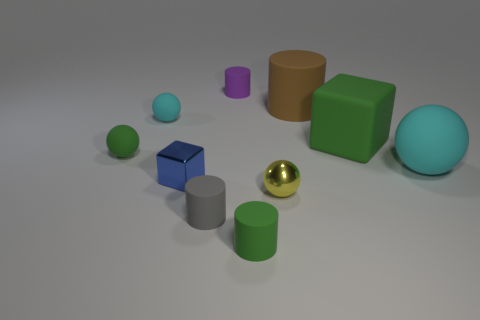Subtract all green rubber spheres. How many spheres are left? 3 Subtract all purple cylinders. How many cylinders are left? 3 Subtract all red balls. Subtract all blue cylinders. How many balls are left? 4 Subtract all cylinders. How many objects are left? 6 Subtract all tiny cyan matte things. Subtract all small purple matte objects. How many objects are left? 8 Add 9 tiny yellow things. How many tiny yellow things are left? 10 Add 6 large brown matte objects. How many large brown matte objects exist? 7 Subtract 0 gray blocks. How many objects are left? 10 